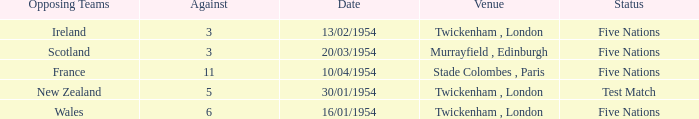What was the venue for the game played on 16/01/1954, when the against was more than 3? Twickenham , London. 